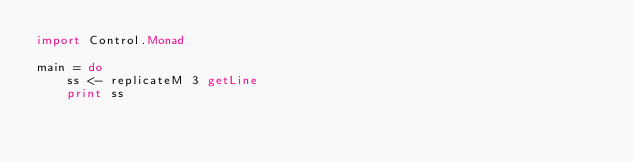Convert code to text. <code><loc_0><loc_0><loc_500><loc_500><_Haskell_>import Control.Monad

main = do  
    ss <- replicateM 3 getLine
    print ss</code> 